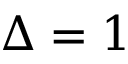<formula> <loc_0><loc_0><loc_500><loc_500>\Delta = 1</formula> 